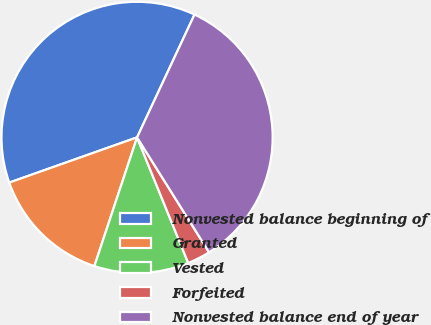<chart> <loc_0><loc_0><loc_500><loc_500><pie_chart><fcel>Nonvested balance beginning of<fcel>Granted<fcel>Vested<fcel>Forfeited<fcel>Nonvested balance end of year<nl><fcel>37.37%<fcel>14.49%<fcel>11.25%<fcel>2.75%<fcel>34.13%<nl></chart> 